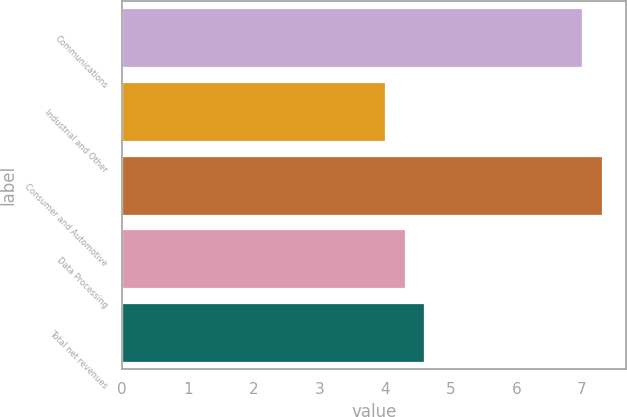<chart> <loc_0><loc_0><loc_500><loc_500><bar_chart><fcel>Communications<fcel>Industrial and Other<fcel>Consumer and Automotive<fcel>Data Processing<fcel>Total net revenues<nl><fcel>7<fcel>4<fcel>7.3<fcel>4.3<fcel>4.6<nl></chart> 